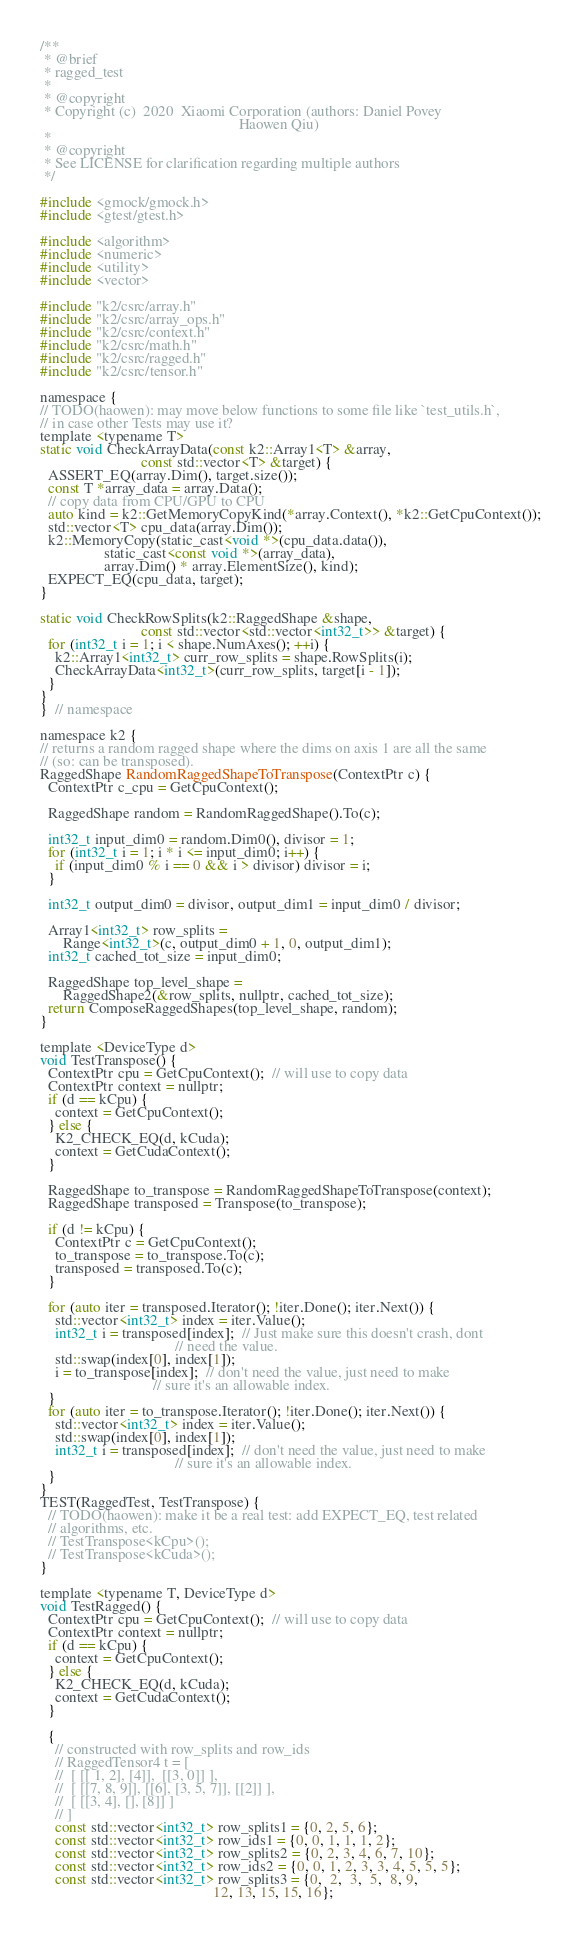<code> <loc_0><loc_0><loc_500><loc_500><_Cuda_>/**
 * @brief
 * ragged_test
 *
 * @copyright
 * Copyright (c)  2020  Xiaomi Corporation (authors: Daniel Povey
                                                     Haowen Qiu)
 *
 * @copyright
 * See LICENSE for clarification regarding multiple authors
 */

#include <gmock/gmock.h>
#include <gtest/gtest.h>

#include <algorithm>
#include <numeric>
#include <utility>
#include <vector>

#include "k2/csrc/array.h"
#include "k2/csrc/array_ops.h"
#include "k2/csrc/context.h"
#include "k2/csrc/math.h"
#include "k2/csrc/ragged.h"
#include "k2/csrc/tensor.h"

namespace {
// TODO(haowen): may move below functions to some file like `test_utils.h`,
// in case other Tests may use it?
template <typename T>
static void CheckArrayData(const k2::Array1<T> &array,
                           const std::vector<T> &target) {
  ASSERT_EQ(array.Dim(), target.size());
  const T *array_data = array.Data();
  // copy data from CPU/GPU to CPU
  auto kind = k2::GetMemoryCopyKind(*array.Context(), *k2::GetCpuContext());
  std::vector<T> cpu_data(array.Dim());
  k2::MemoryCopy(static_cast<void *>(cpu_data.data()),
                 static_cast<const void *>(array_data),
                 array.Dim() * array.ElementSize(), kind);
  EXPECT_EQ(cpu_data, target);
}

static void CheckRowSplits(k2::RaggedShape &shape,
                           const std::vector<std::vector<int32_t>> &target) {
  for (int32_t i = 1; i < shape.NumAxes(); ++i) {
    k2::Array1<int32_t> curr_row_splits = shape.RowSplits(i);
    CheckArrayData<int32_t>(curr_row_splits, target[i - 1]);
  }
}
}  // namespace

namespace k2 {
// returns a random ragged shape where the dims on axis 1 are all the same
// (so: can be transposed).
RaggedShape RandomRaggedShapeToTranspose(ContextPtr c) {
  ContextPtr c_cpu = GetCpuContext();

  RaggedShape random = RandomRaggedShape().To(c);

  int32_t input_dim0 = random.Dim0(), divisor = 1;
  for (int32_t i = 1; i * i <= input_dim0; i++) {
    if (input_dim0 % i == 0 && i > divisor) divisor = i;
  }

  int32_t output_dim0 = divisor, output_dim1 = input_dim0 / divisor;

  Array1<int32_t> row_splits =
      Range<int32_t>(c, output_dim0 + 1, 0, output_dim1);
  int32_t cached_tot_size = input_dim0;

  RaggedShape top_level_shape =
      RaggedShape2(&row_splits, nullptr, cached_tot_size);
  return ComposeRaggedShapes(top_level_shape, random);
}

template <DeviceType d>
void TestTranspose() {
  ContextPtr cpu = GetCpuContext();  // will use to copy data
  ContextPtr context = nullptr;
  if (d == kCpu) {
    context = GetCpuContext();
  } else {
    K2_CHECK_EQ(d, kCuda);
    context = GetCudaContext();
  }

  RaggedShape to_transpose = RandomRaggedShapeToTranspose(context);
  RaggedShape transposed = Transpose(to_transpose);

  if (d != kCpu) {
    ContextPtr c = GetCpuContext();
    to_transpose = to_transpose.To(c);
    transposed = transposed.To(c);
  }

  for (auto iter = transposed.Iterator(); !iter.Done(); iter.Next()) {
    std::vector<int32_t> index = iter.Value();
    int32_t i = transposed[index];  // Just make sure this doesn't crash, dont
                                    // need the value.
    std::swap(index[0], index[1]);
    i = to_transpose[index];  // don't need the value, just need to make
                              // sure it's an allowable index.
  }
  for (auto iter = to_transpose.Iterator(); !iter.Done(); iter.Next()) {
    std::vector<int32_t> index = iter.Value();
    std::swap(index[0], index[1]);
    int32_t i = transposed[index];  // don't need the value, just need to make
                                    // sure it's an allowable index.
  }
}
TEST(RaggedTest, TestTranspose) {
  // TODO(haowen): make it be a real test: add EXPECT_EQ, test related
  // algorithms, etc.
  // TestTranspose<kCpu>();
  // TestTranspose<kCuda>();
}

template <typename T, DeviceType d>
void TestRagged() {
  ContextPtr cpu = GetCpuContext();  // will use to copy data
  ContextPtr context = nullptr;
  if (d == kCpu) {
    context = GetCpuContext();
  } else {
    K2_CHECK_EQ(d, kCuda);
    context = GetCudaContext();
  }

  {
    // constructed with row_splits and row_ids
    // RaggedTensor4 t = [
    //  [ [[ 1, 2], [4]],  [[3, 0]] ],
    //  [ [[7, 8, 9]], [[6], [3, 5, 7]], [[2]] ],
    //  [ [[3, 4], [], [8]] ]
    // ]
    const std::vector<int32_t> row_splits1 = {0, 2, 5, 6};
    const std::vector<int32_t> row_ids1 = {0, 0, 1, 1, 1, 2};
    const std::vector<int32_t> row_splits2 = {0, 2, 3, 4, 6, 7, 10};
    const std::vector<int32_t> row_ids2 = {0, 0, 1, 2, 3, 3, 4, 5, 5, 5};
    const std::vector<int32_t> row_splits3 = {0,  2,  3,  5,  8, 9,
                                              12, 13, 15, 15, 16};</code> 